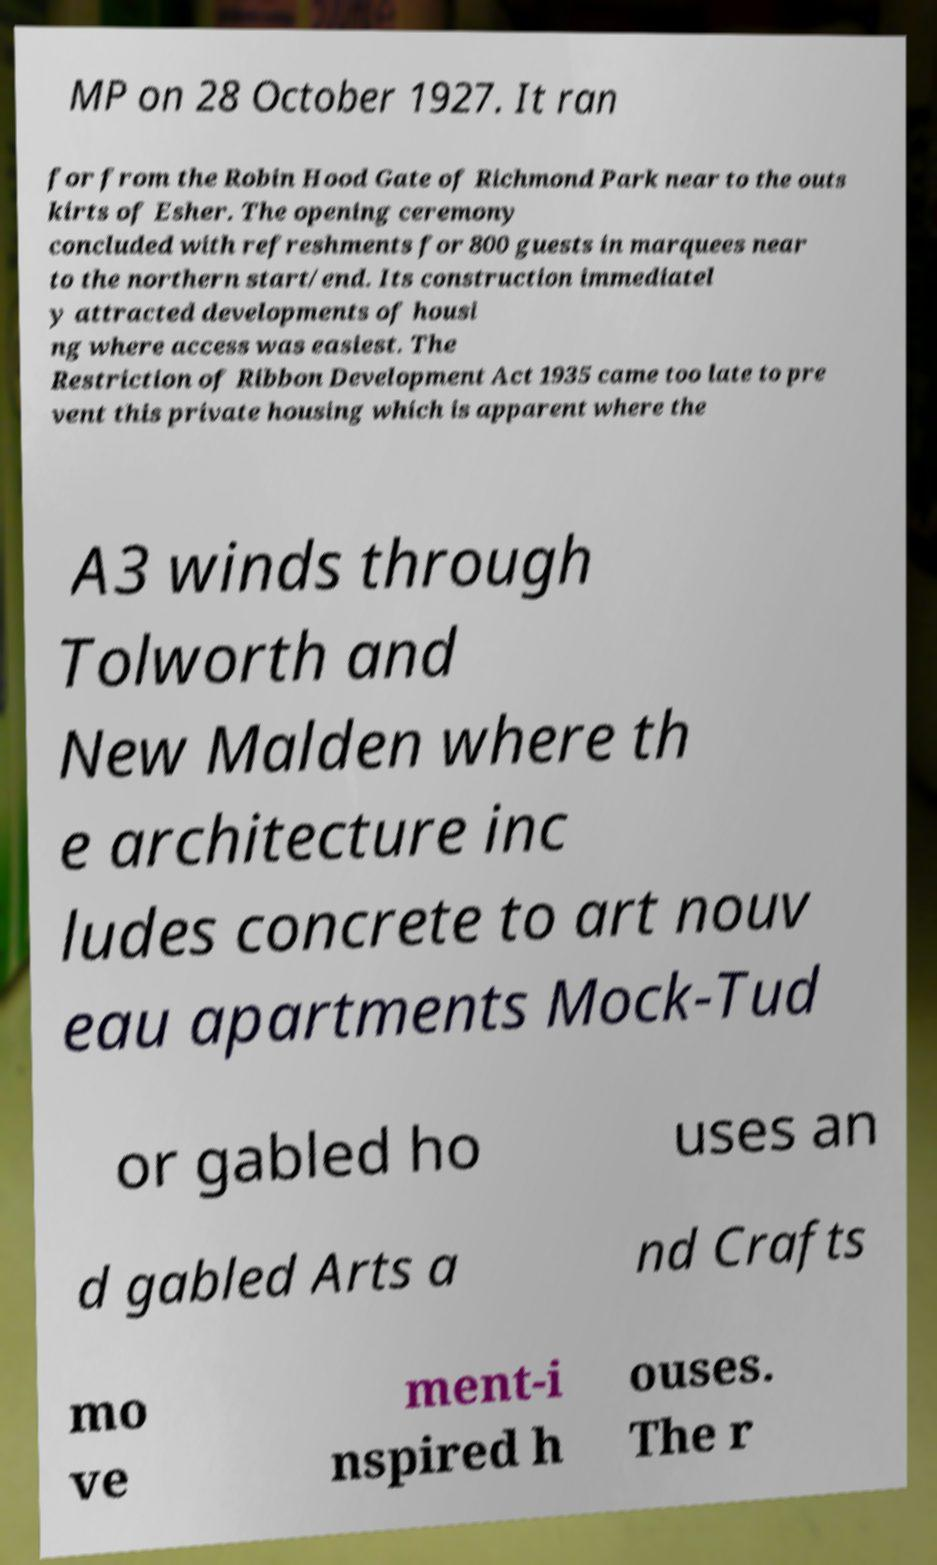Can you accurately transcribe the text from the provided image for me? MP on 28 October 1927. It ran for from the Robin Hood Gate of Richmond Park near to the outs kirts of Esher. The opening ceremony concluded with refreshments for 800 guests in marquees near to the northern start/end. Its construction immediatel y attracted developments of housi ng where access was easiest. The Restriction of Ribbon Development Act 1935 came too late to pre vent this private housing which is apparent where the A3 winds through Tolworth and New Malden where th e architecture inc ludes concrete to art nouv eau apartments Mock-Tud or gabled ho uses an d gabled Arts a nd Crafts mo ve ment-i nspired h ouses. The r 